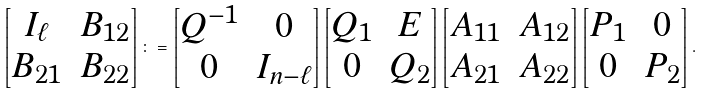Convert formula to latex. <formula><loc_0><loc_0><loc_500><loc_500>\begin{bmatrix} I _ { \ell } & B _ { 1 2 } \\ B _ { 2 1 } & B _ { 2 2 } \end{bmatrix} \colon = \begin{bmatrix} Q ^ { - 1 } & 0 \\ 0 & I _ { n - \ell } \end{bmatrix} \begin{bmatrix} Q _ { 1 } & E \\ 0 & Q _ { 2 } \end{bmatrix} \begin{bmatrix} A _ { 1 1 } & A _ { 1 2 } \\ A _ { 2 1 } & A _ { 2 2 } \end{bmatrix} \begin{bmatrix} P _ { 1 } & 0 \\ 0 & P _ { 2 } \end{bmatrix} .</formula> 